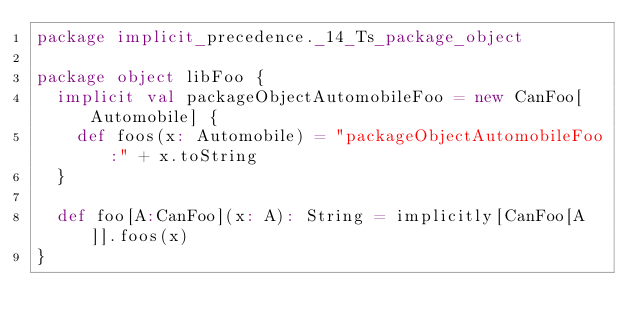Convert code to text. <code><loc_0><loc_0><loc_500><loc_500><_Scala_>package implicit_precedence._14_Ts_package_object

package object libFoo {
  implicit val packageObjectAutomobileFoo = new CanFoo[Automobile] {
    def foos(x: Automobile) = "packageObjectAutomobileFoo:" + x.toString
  }

  def foo[A:CanFoo](x: A): String = implicitly[CanFoo[A]].foos(x)
}
</code> 